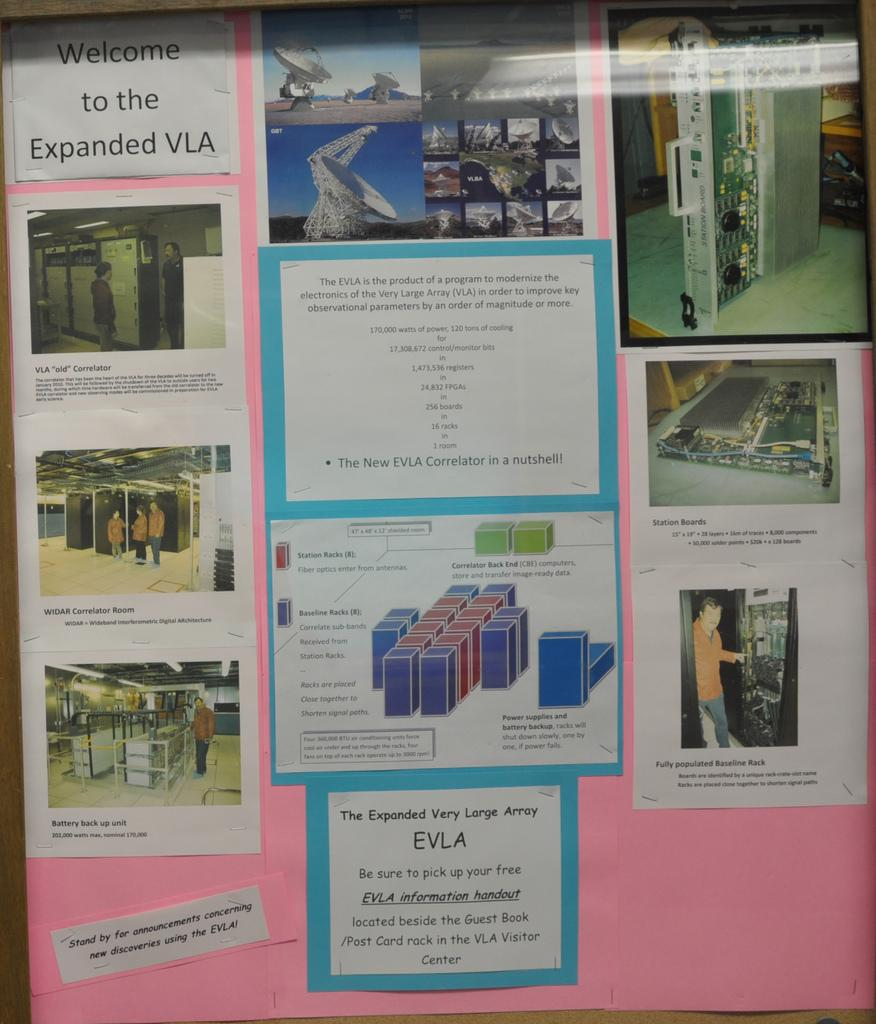<image>
Summarize the visual content of the image. Pink board with a piece of paper that says "Welcome to the Expanded VLA". 